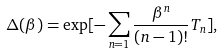<formula> <loc_0><loc_0><loc_500><loc_500>\Delta ( \beta ) = \exp [ - \sum _ { n = 1 } \frac { \beta ^ { n } } { ( n - 1 ) ! } T _ { n } ] ,</formula> 